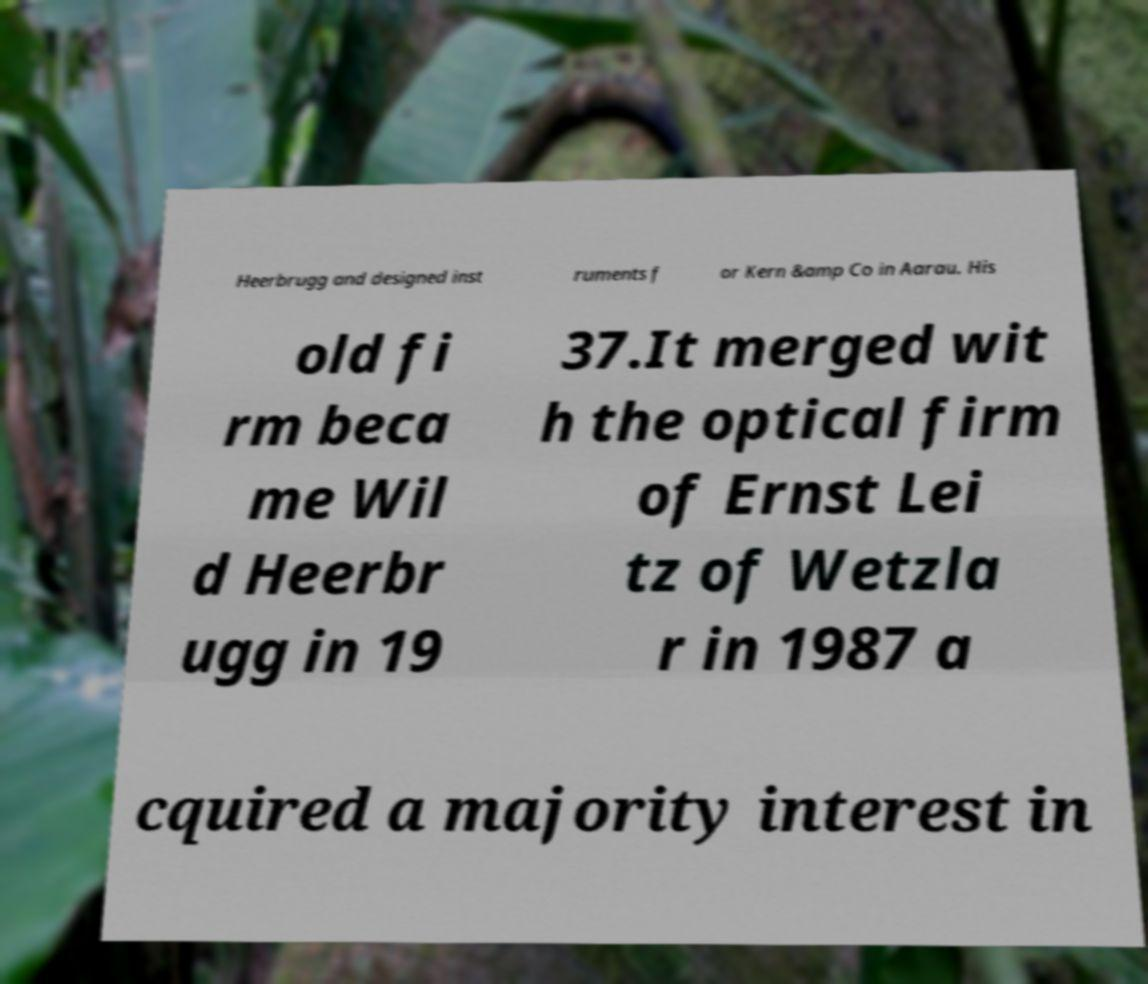Can you read and provide the text displayed in the image?This photo seems to have some interesting text. Can you extract and type it out for me? Heerbrugg and designed inst ruments f or Kern &amp Co in Aarau. His old fi rm beca me Wil d Heerbr ugg in 19 37.It merged wit h the optical firm of Ernst Lei tz of Wetzla r in 1987 a cquired a majority interest in 